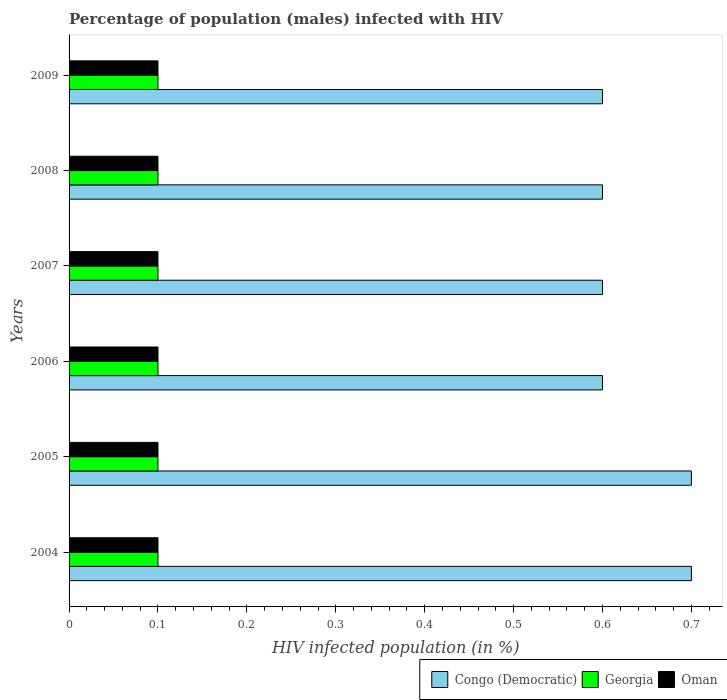How many different coloured bars are there?
Provide a succinct answer. 3. Are the number of bars per tick equal to the number of legend labels?
Provide a succinct answer. Yes. Are the number of bars on each tick of the Y-axis equal?
Give a very brief answer. Yes. What is the percentage of HIV infected male population in Georgia in 2007?
Offer a terse response. 0.1. In which year was the percentage of HIV infected male population in Oman maximum?
Offer a very short reply. 2004. In which year was the percentage of HIV infected male population in Georgia minimum?
Keep it short and to the point. 2004. What is the average percentage of HIV infected male population in Congo (Democratic) per year?
Provide a succinct answer. 0.63. In the year 2009, what is the difference between the percentage of HIV infected male population in Georgia and percentage of HIV infected male population in Oman?
Offer a very short reply. 0. In how many years, is the percentage of HIV infected male population in Georgia greater than 0.42000000000000004 %?
Provide a succinct answer. 0. What is the ratio of the percentage of HIV infected male population in Congo (Democratic) in 2005 to that in 2007?
Your answer should be compact. 1.17. Is the percentage of HIV infected male population in Congo (Democratic) in 2005 less than that in 2006?
Ensure brevity in your answer.  No. In how many years, is the percentage of HIV infected male population in Georgia greater than the average percentage of HIV infected male population in Georgia taken over all years?
Offer a very short reply. 6. What does the 1st bar from the top in 2008 represents?
Ensure brevity in your answer.  Oman. What does the 1st bar from the bottom in 2004 represents?
Give a very brief answer. Congo (Democratic). Is it the case that in every year, the sum of the percentage of HIV infected male population in Congo (Democratic) and percentage of HIV infected male population in Oman is greater than the percentage of HIV infected male population in Georgia?
Keep it short and to the point. Yes. How many bars are there?
Provide a short and direct response. 18. Are all the bars in the graph horizontal?
Offer a terse response. Yes. Does the graph contain any zero values?
Provide a short and direct response. No. Does the graph contain grids?
Give a very brief answer. No. Where does the legend appear in the graph?
Your response must be concise. Bottom right. How many legend labels are there?
Give a very brief answer. 3. How are the legend labels stacked?
Provide a succinct answer. Horizontal. What is the title of the graph?
Give a very brief answer. Percentage of population (males) infected with HIV. Does "Micronesia" appear as one of the legend labels in the graph?
Keep it short and to the point. No. What is the label or title of the X-axis?
Offer a terse response. HIV infected population (in %). What is the label or title of the Y-axis?
Your answer should be compact. Years. What is the HIV infected population (in %) of Congo (Democratic) in 2004?
Ensure brevity in your answer.  0.7. What is the HIV infected population (in %) in Georgia in 2004?
Provide a succinct answer. 0.1. What is the HIV infected population (in %) of Congo (Democratic) in 2005?
Provide a short and direct response. 0.7. What is the HIV infected population (in %) of Congo (Democratic) in 2006?
Ensure brevity in your answer.  0.6. What is the HIV infected population (in %) of Georgia in 2006?
Provide a short and direct response. 0.1. What is the HIV infected population (in %) of Congo (Democratic) in 2007?
Your answer should be very brief. 0.6. What is the HIV infected population (in %) in Oman in 2007?
Give a very brief answer. 0.1. What is the HIV infected population (in %) of Oman in 2009?
Offer a very short reply. 0.1. Across all years, what is the maximum HIV infected population (in %) in Congo (Democratic)?
Provide a succinct answer. 0.7. Across all years, what is the maximum HIV infected population (in %) of Georgia?
Keep it short and to the point. 0.1. Across all years, what is the maximum HIV infected population (in %) in Oman?
Ensure brevity in your answer.  0.1. Across all years, what is the minimum HIV infected population (in %) of Congo (Democratic)?
Offer a terse response. 0.6. What is the total HIV infected population (in %) in Georgia in the graph?
Your response must be concise. 0.6. What is the total HIV infected population (in %) in Oman in the graph?
Ensure brevity in your answer.  0.6. What is the difference between the HIV infected population (in %) in Congo (Democratic) in 2004 and that in 2005?
Your answer should be very brief. 0. What is the difference between the HIV infected population (in %) of Congo (Democratic) in 2004 and that in 2007?
Keep it short and to the point. 0.1. What is the difference between the HIV infected population (in %) of Oman in 2004 and that in 2008?
Your response must be concise. 0. What is the difference between the HIV infected population (in %) in Georgia in 2004 and that in 2009?
Your answer should be compact. 0. What is the difference between the HIV infected population (in %) of Oman in 2004 and that in 2009?
Offer a terse response. 0. What is the difference between the HIV infected population (in %) in Congo (Democratic) in 2005 and that in 2007?
Offer a terse response. 0.1. What is the difference between the HIV infected population (in %) of Georgia in 2005 and that in 2007?
Give a very brief answer. 0. What is the difference between the HIV infected population (in %) in Oman in 2005 and that in 2007?
Ensure brevity in your answer.  0. What is the difference between the HIV infected population (in %) of Georgia in 2005 and that in 2008?
Provide a succinct answer. 0. What is the difference between the HIV infected population (in %) in Congo (Democratic) in 2005 and that in 2009?
Make the answer very short. 0.1. What is the difference between the HIV infected population (in %) in Oman in 2005 and that in 2009?
Provide a short and direct response. 0. What is the difference between the HIV infected population (in %) in Georgia in 2006 and that in 2007?
Your answer should be compact. 0. What is the difference between the HIV infected population (in %) of Oman in 2006 and that in 2007?
Offer a terse response. 0. What is the difference between the HIV infected population (in %) of Georgia in 2006 and that in 2008?
Keep it short and to the point. 0. What is the difference between the HIV infected population (in %) in Congo (Democratic) in 2006 and that in 2009?
Keep it short and to the point. 0. What is the difference between the HIV infected population (in %) in Georgia in 2006 and that in 2009?
Provide a succinct answer. 0. What is the difference between the HIV infected population (in %) of Georgia in 2007 and that in 2008?
Your response must be concise. 0. What is the difference between the HIV infected population (in %) of Congo (Democratic) in 2007 and that in 2009?
Provide a succinct answer. 0. What is the difference between the HIV infected population (in %) in Georgia in 2007 and that in 2009?
Ensure brevity in your answer.  0. What is the difference between the HIV infected population (in %) of Oman in 2007 and that in 2009?
Ensure brevity in your answer.  0. What is the difference between the HIV infected population (in %) in Congo (Democratic) in 2008 and that in 2009?
Offer a terse response. 0. What is the difference between the HIV infected population (in %) of Congo (Democratic) in 2004 and the HIV infected population (in %) of Georgia in 2005?
Give a very brief answer. 0.6. What is the difference between the HIV infected population (in %) in Congo (Democratic) in 2004 and the HIV infected population (in %) in Oman in 2005?
Provide a short and direct response. 0.6. What is the difference between the HIV infected population (in %) of Congo (Democratic) in 2004 and the HIV infected population (in %) of Georgia in 2006?
Offer a terse response. 0.6. What is the difference between the HIV infected population (in %) of Congo (Democratic) in 2004 and the HIV infected population (in %) of Oman in 2006?
Offer a terse response. 0.6. What is the difference between the HIV infected population (in %) of Georgia in 2004 and the HIV infected population (in %) of Oman in 2006?
Give a very brief answer. 0. What is the difference between the HIV infected population (in %) of Congo (Democratic) in 2004 and the HIV infected population (in %) of Georgia in 2008?
Offer a very short reply. 0.6. What is the difference between the HIV infected population (in %) of Congo (Democratic) in 2004 and the HIV infected population (in %) of Georgia in 2009?
Give a very brief answer. 0.6. What is the difference between the HIV infected population (in %) of Georgia in 2004 and the HIV infected population (in %) of Oman in 2009?
Provide a succinct answer. 0. What is the difference between the HIV infected population (in %) in Georgia in 2005 and the HIV infected population (in %) in Oman in 2006?
Your answer should be compact. 0. What is the difference between the HIV infected population (in %) in Congo (Democratic) in 2005 and the HIV infected population (in %) in Georgia in 2007?
Your response must be concise. 0.6. What is the difference between the HIV infected population (in %) in Georgia in 2005 and the HIV infected population (in %) in Oman in 2007?
Provide a succinct answer. 0. What is the difference between the HIV infected population (in %) in Congo (Democratic) in 2005 and the HIV infected population (in %) in Georgia in 2008?
Make the answer very short. 0.6. What is the difference between the HIV infected population (in %) of Congo (Democratic) in 2005 and the HIV infected population (in %) of Oman in 2008?
Your answer should be compact. 0.6. What is the difference between the HIV infected population (in %) of Congo (Democratic) in 2005 and the HIV infected population (in %) of Georgia in 2009?
Provide a succinct answer. 0.6. What is the difference between the HIV infected population (in %) in Congo (Democratic) in 2005 and the HIV infected population (in %) in Oman in 2009?
Provide a short and direct response. 0.6. What is the difference between the HIV infected population (in %) in Congo (Democratic) in 2006 and the HIV infected population (in %) in Georgia in 2007?
Your response must be concise. 0.5. What is the difference between the HIV infected population (in %) in Congo (Democratic) in 2006 and the HIV infected population (in %) in Oman in 2007?
Your answer should be very brief. 0.5. What is the difference between the HIV infected population (in %) of Congo (Democratic) in 2006 and the HIV infected population (in %) of Georgia in 2008?
Provide a short and direct response. 0.5. What is the difference between the HIV infected population (in %) of Congo (Democratic) in 2006 and the HIV infected population (in %) of Oman in 2008?
Make the answer very short. 0.5. What is the difference between the HIV infected population (in %) in Georgia in 2006 and the HIV infected population (in %) in Oman in 2008?
Provide a succinct answer. 0. What is the difference between the HIV infected population (in %) of Congo (Democratic) in 2006 and the HIV infected population (in %) of Georgia in 2009?
Provide a short and direct response. 0.5. What is the difference between the HIV infected population (in %) in Congo (Democratic) in 2006 and the HIV infected population (in %) in Oman in 2009?
Ensure brevity in your answer.  0.5. What is the difference between the HIV infected population (in %) in Congo (Democratic) in 2007 and the HIV infected population (in %) in Oman in 2008?
Your answer should be compact. 0.5. What is the difference between the HIV infected population (in %) in Georgia in 2007 and the HIV infected population (in %) in Oman in 2008?
Offer a very short reply. 0. What is the difference between the HIV infected population (in %) in Congo (Democratic) in 2007 and the HIV infected population (in %) in Georgia in 2009?
Offer a very short reply. 0.5. What is the difference between the HIV infected population (in %) of Congo (Democratic) in 2008 and the HIV infected population (in %) of Oman in 2009?
Ensure brevity in your answer.  0.5. What is the average HIV infected population (in %) of Congo (Democratic) per year?
Keep it short and to the point. 0.63. What is the average HIV infected population (in %) of Oman per year?
Give a very brief answer. 0.1. In the year 2004, what is the difference between the HIV infected population (in %) in Congo (Democratic) and HIV infected population (in %) in Georgia?
Give a very brief answer. 0.6. In the year 2004, what is the difference between the HIV infected population (in %) of Georgia and HIV infected population (in %) of Oman?
Offer a terse response. 0. In the year 2005, what is the difference between the HIV infected population (in %) of Congo (Democratic) and HIV infected population (in %) of Georgia?
Make the answer very short. 0.6. In the year 2005, what is the difference between the HIV infected population (in %) of Georgia and HIV infected population (in %) of Oman?
Ensure brevity in your answer.  0. In the year 2006, what is the difference between the HIV infected population (in %) in Congo (Democratic) and HIV infected population (in %) in Georgia?
Provide a short and direct response. 0.5. In the year 2006, what is the difference between the HIV infected population (in %) of Georgia and HIV infected population (in %) of Oman?
Provide a succinct answer. 0. In the year 2007, what is the difference between the HIV infected population (in %) of Congo (Democratic) and HIV infected population (in %) of Oman?
Ensure brevity in your answer.  0.5. In the year 2008, what is the difference between the HIV infected population (in %) in Congo (Democratic) and HIV infected population (in %) in Georgia?
Offer a terse response. 0.5. In the year 2008, what is the difference between the HIV infected population (in %) of Congo (Democratic) and HIV infected population (in %) of Oman?
Your answer should be very brief. 0.5. In the year 2008, what is the difference between the HIV infected population (in %) of Georgia and HIV infected population (in %) of Oman?
Provide a short and direct response. 0. In the year 2009, what is the difference between the HIV infected population (in %) in Congo (Democratic) and HIV infected population (in %) in Georgia?
Your response must be concise. 0.5. In the year 2009, what is the difference between the HIV infected population (in %) of Georgia and HIV infected population (in %) of Oman?
Make the answer very short. 0. What is the ratio of the HIV infected population (in %) of Georgia in 2004 to that in 2005?
Your response must be concise. 1. What is the ratio of the HIV infected population (in %) of Congo (Democratic) in 2004 to that in 2006?
Provide a short and direct response. 1.17. What is the ratio of the HIV infected population (in %) of Oman in 2004 to that in 2006?
Your response must be concise. 1. What is the ratio of the HIV infected population (in %) of Congo (Democratic) in 2004 to that in 2007?
Provide a succinct answer. 1.17. What is the ratio of the HIV infected population (in %) of Georgia in 2004 to that in 2008?
Provide a short and direct response. 1. What is the ratio of the HIV infected population (in %) of Oman in 2004 to that in 2009?
Offer a very short reply. 1. What is the ratio of the HIV infected population (in %) of Congo (Democratic) in 2005 to that in 2006?
Keep it short and to the point. 1.17. What is the ratio of the HIV infected population (in %) in Oman in 2005 to that in 2006?
Ensure brevity in your answer.  1. What is the ratio of the HIV infected population (in %) in Congo (Democratic) in 2005 to that in 2007?
Keep it short and to the point. 1.17. What is the ratio of the HIV infected population (in %) of Georgia in 2005 to that in 2007?
Your response must be concise. 1. What is the ratio of the HIV infected population (in %) in Georgia in 2005 to that in 2008?
Make the answer very short. 1. What is the ratio of the HIV infected population (in %) in Oman in 2005 to that in 2008?
Offer a terse response. 1. What is the ratio of the HIV infected population (in %) in Georgia in 2005 to that in 2009?
Your response must be concise. 1. What is the ratio of the HIV infected population (in %) of Oman in 2005 to that in 2009?
Your response must be concise. 1. What is the ratio of the HIV infected population (in %) of Georgia in 2006 to that in 2007?
Your answer should be compact. 1. What is the ratio of the HIV infected population (in %) in Oman in 2006 to that in 2007?
Provide a succinct answer. 1. What is the ratio of the HIV infected population (in %) in Georgia in 2006 to that in 2008?
Offer a very short reply. 1. What is the ratio of the HIV infected population (in %) of Oman in 2006 to that in 2008?
Give a very brief answer. 1. What is the ratio of the HIV infected population (in %) in Congo (Democratic) in 2006 to that in 2009?
Keep it short and to the point. 1. What is the ratio of the HIV infected population (in %) of Congo (Democratic) in 2007 to that in 2008?
Give a very brief answer. 1. What is the ratio of the HIV infected population (in %) of Oman in 2007 to that in 2008?
Keep it short and to the point. 1. What is the ratio of the HIV infected population (in %) in Congo (Democratic) in 2007 to that in 2009?
Offer a terse response. 1. What is the ratio of the HIV infected population (in %) of Georgia in 2007 to that in 2009?
Ensure brevity in your answer.  1. What is the ratio of the HIV infected population (in %) in Congo (Democratic) in 2008 to that in 2009?
Your answer should be very brief. 1. What is the difference between the highest and the second highest HIV infected population (in %) of Congo (Democratic)?
Your response must be concise. 0. What is the difference between the highest and the second highest HIV infected population (in %) in Oman?
Offer a very short reply. 0. What is the difference between the highest and the lowest HIV infected population (in %) of Congo (Democratic)?
Your answer should be very brief. 0.1. What is the difference between the highest and the lowest HIV infected population (in %) in Oman?
Make the answer very short. 0. 